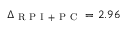Convert formula to latex. <formula><loc_0><loc_0><loc_500><loc_500>\Delta _ { R P I + P C } = 2 . 9 6</formula> 